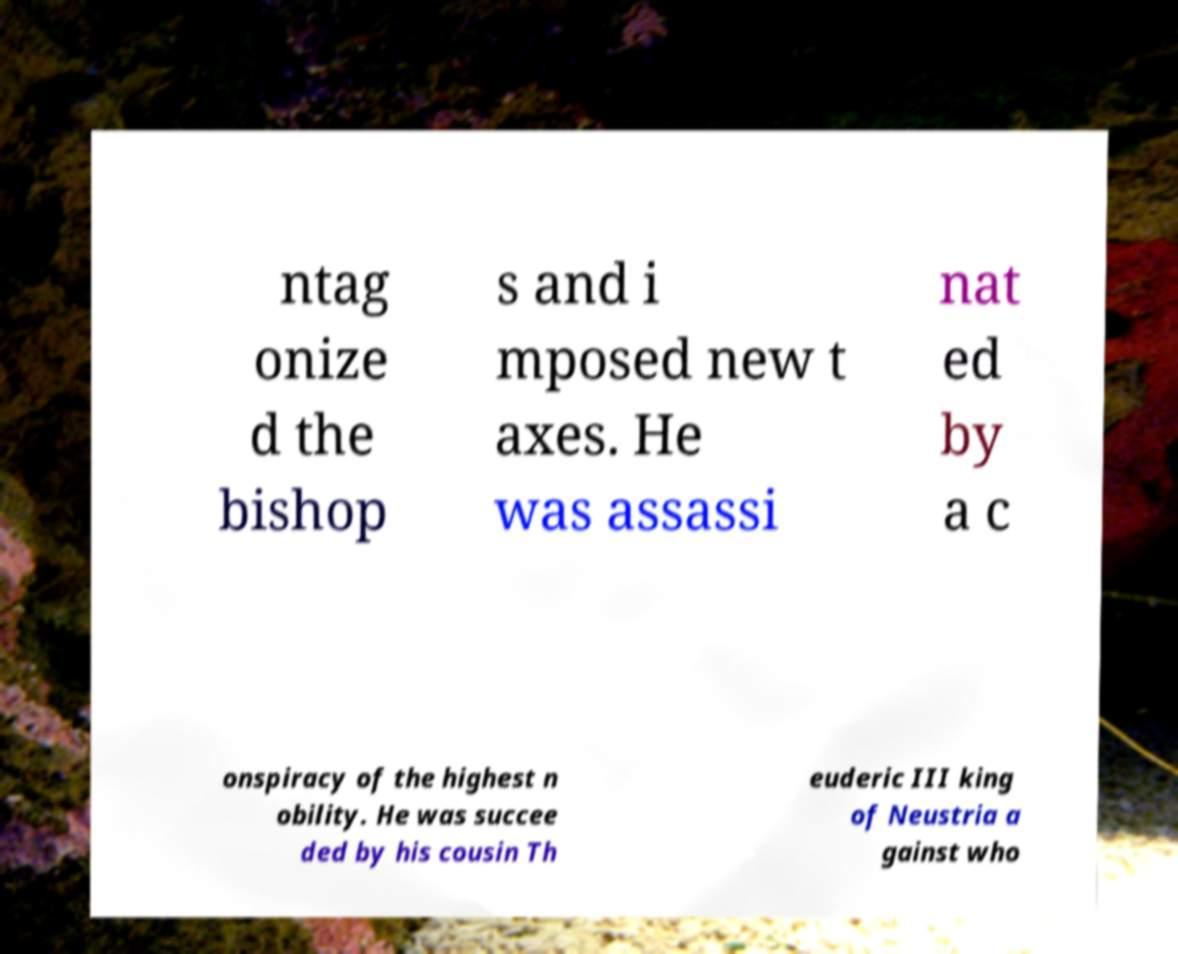What messages or text are displayed in this image? I need them in a readable, typed format. ntag onize d the bishop s and i mposed new t axes. He was assassi nat ed by a c onspiracy of the highest n obility. He was succee ded by his cousin Th euderic III king of Neustria a gainst who 